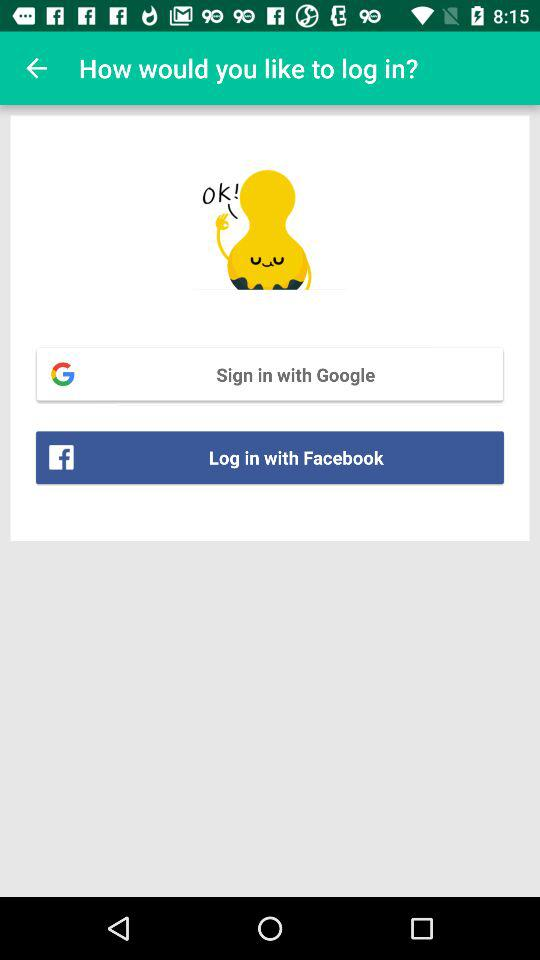How can we log in? You can log in with "Google" and "Facebook". 